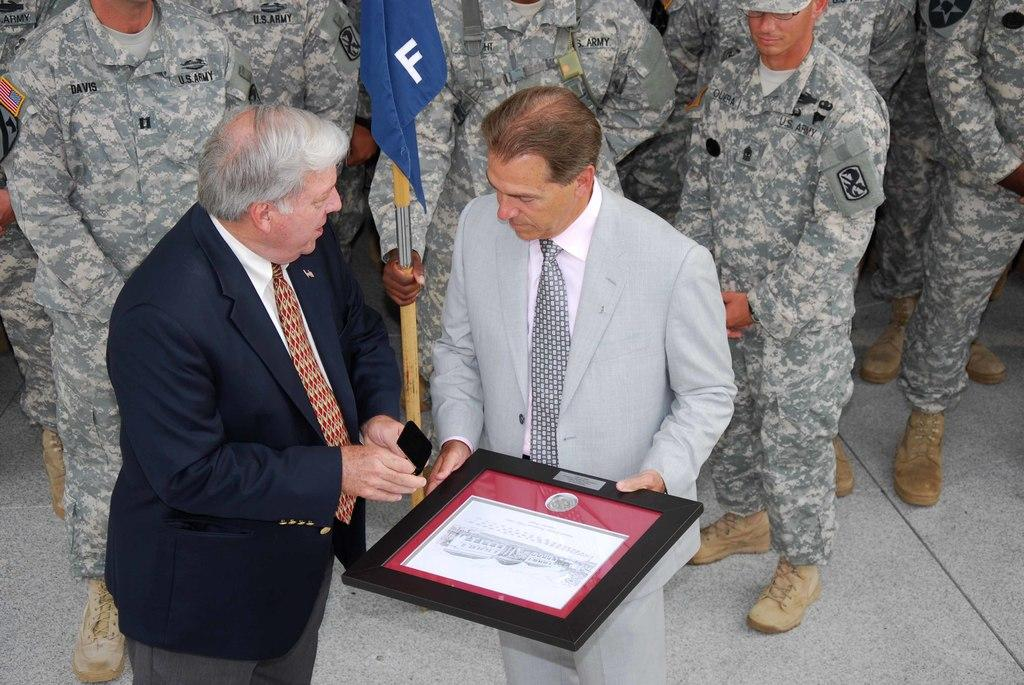How many people are in the center of the image? There are two persons standing in the middle of the image. What are the two persons holding? The two persons are holding a frame and a mobile phone. Are there any other people visible in the image? Yes, there are people standing behind the two persons. What are the people behind holding? The people behind are holding a flag. What type of sidewalk can be seen in the image? There is no sidewalk present in the image. What kind of fuel is being used by the persons in the image? There is no mention of fuel or any vehicles in the image. 